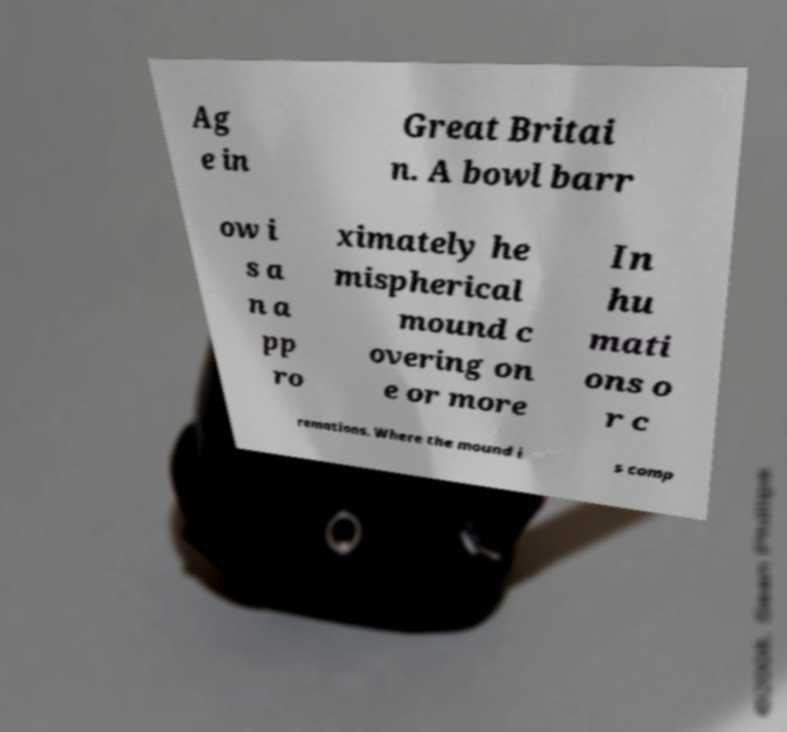Please read and relay the text visible in this image. What does it say? Ag e in Great Britai n. A bowl barr ow i s a n a pp ro ximately he mispherical mound c overing on e or more In hu mati ons o r c remations. Where the mound i s comp 